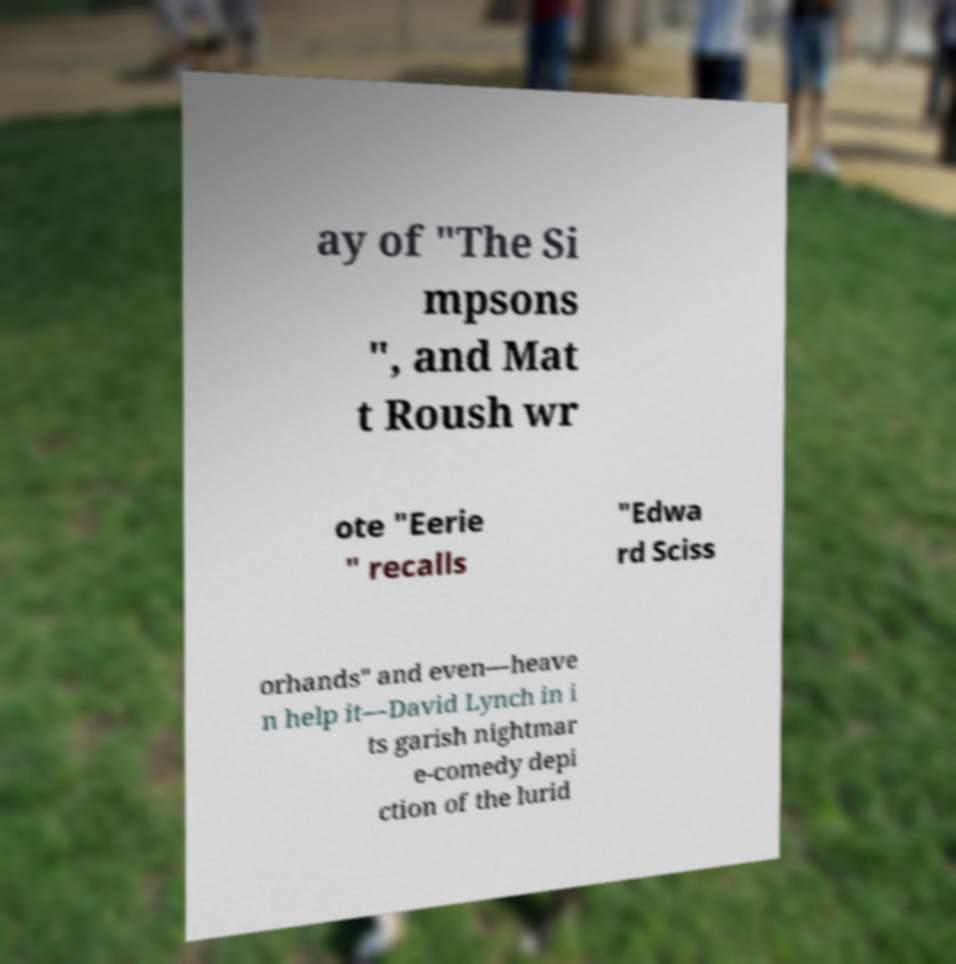Could you extract and type out the text from this image? ay of "The Si mpsons ", and Mat t Roush wr ote "Eerie " recalls "Edwa rd Sciss orhands" and even—heave n help it—David Lynch in i ts garish nightmar e-comedy depi ction of the lurid 